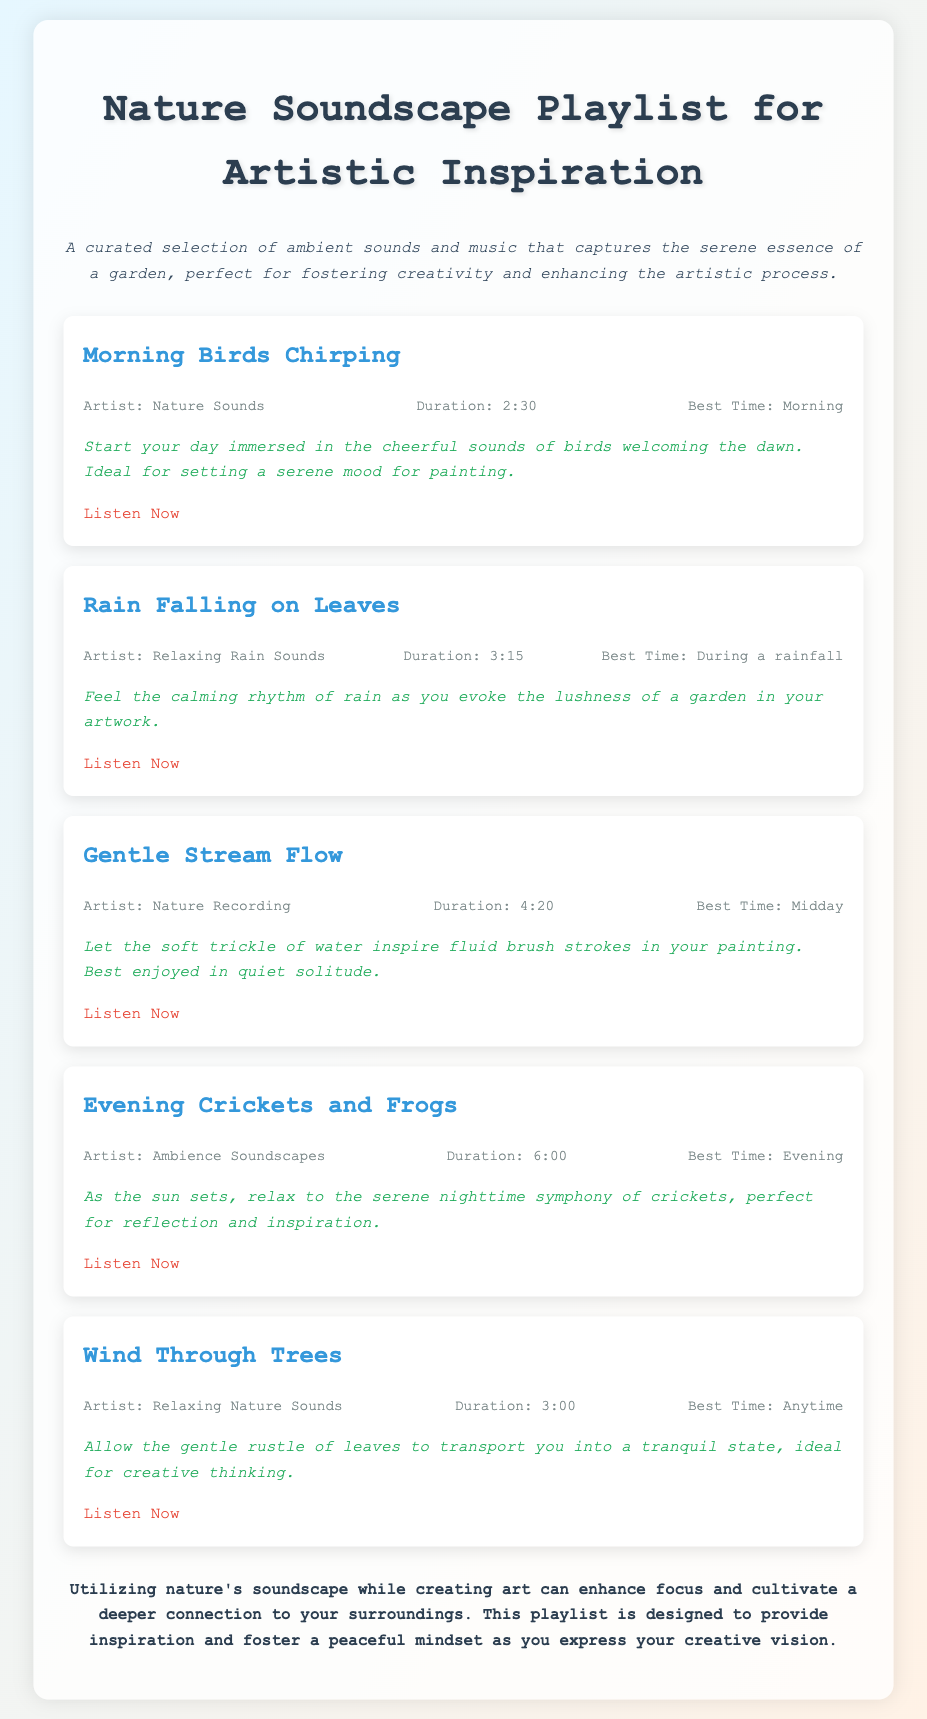What is the title of the note? The title is prominently displayed at the top of the document.
Answer: Nature Soundscape Playlist for Artistic Inspiration How many tracks are listed in the document? By counting each individual track section, we find there are five tracks.
Answer: 5 What is the best time to listen to "Morning Birds Chirping"? This information is provided within the track details, indicating its recommended listening period.
Answer: Morning Who is the artist for "Gentle Stream Flow"? The artist's name is given in the track details section for this specific track.
Answer: Nature Recording What is the duration of "Rain Falling on Leaves"? The specific time duration is mentioned in the track information for that song.
Answer: 3:15 Which track is longest in duration? By comparing the durations of all tracks, we assess which is the longest.
Answer: Evening Crickets and Frogs What type of sounds is included in the playlist? The playlist is described as a collection, referring to the ambiance it evokes.
Answer: Ambient sounds and music What is the suggested listening time for "Wind Through Trees"? This listening time is indicated in the track's details as the ideal time for engagement.
Answer: Anytime What purpose does the playlist serve for artists? This information is discussed in the concluding remarks of the document.
Answer: Artistic inspiration 